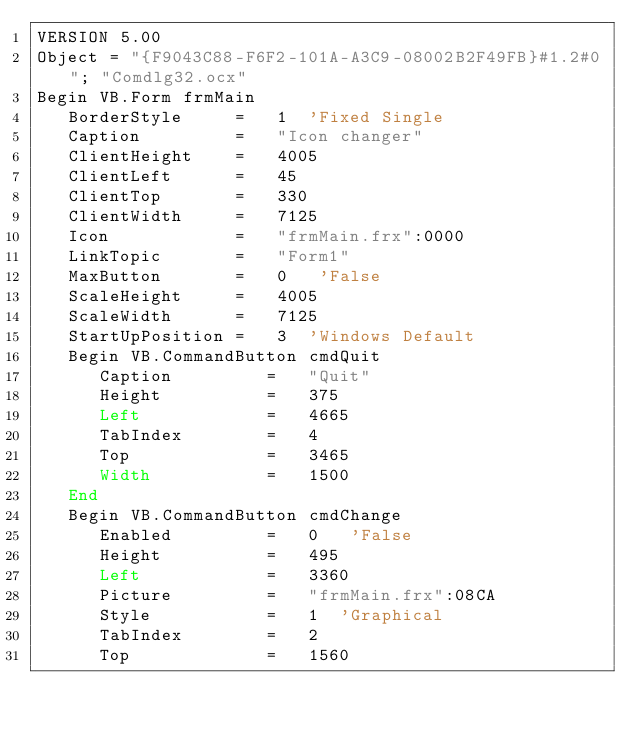Convert code to text. <code><loc_0><loc_0><loc_500><loc_500><_VisualBasic_>VERSION 5.00
Object = "{F9043C88-F6F2-101A-A3C9-08002B2F49FB}#1.2#0"; "Comdlg32.ocx"
Begin VB.Form frmMain 
   BorderStyle     =   1  'Fixed Single
   Caption         =   "Icon changer"
   ClientHeight    =   4005
   ClientLeft      =   45
   ClientTop       =   330
   ClientWidth     =   7125
   Icon            =   "frmMain.frx":0000
   LinkTopic       =   "Form1"
   MaxButton       =   0   'False
   ScaleHeight     =   4005
   ScaleWidth      =   7125
   StartUpPosition =   3  'Windows Default
   Begin VB.CommandButton cmdQuit 
      Caption         =   "Quit"
      Height          =   375
      Left            =   4665
      TabIndex        =   4
      Top             =   3465
      Width           =   1500
   End
   Begin VB.CommandButton cmdChange 
      Enabled         =   0   'False
      Height          =   495
      Left            =   3360
      Picture         =   "frmMain.frx":08CA
      Style           =   1  'Graphical
      TabIndex        =   2
      Top             =   1560</code> 